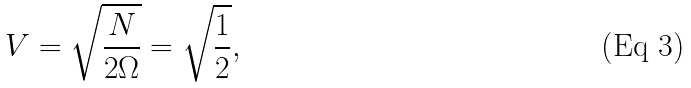Convert formula to latex. <formula><loc_0><loc_0><loc_500><loc_500>V = \sqrt { \frac { N } { 2 \Omega } } = \sqrt { \frac { 1 } { 2 } } ,</formula> 